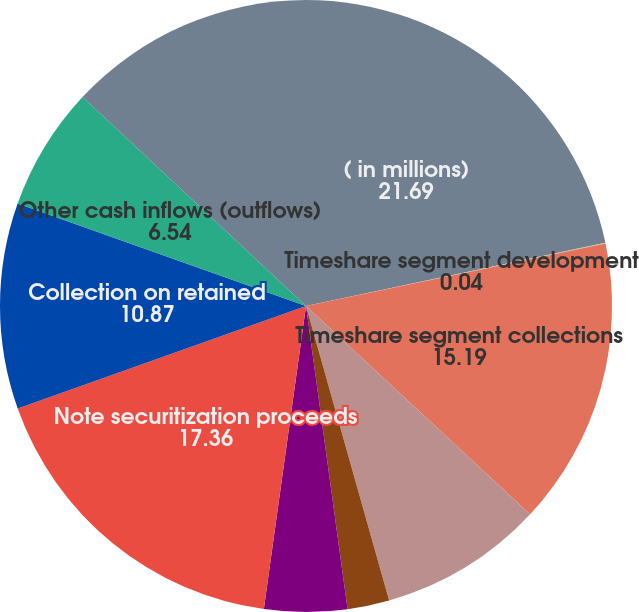Convert chart to OTSL. <chart><loc_0><loc_0><loc_500><loc_500><pie_chart><fcel>( in millions)<fcel>Timeshare segment development<fcel>Timeshare segment collections<fcel>Note repurchases<fcel>Financially reportable sales<fcel>Note securitization gains<fcel>Note securitization proceeds<fcel>Collection on retained<fcel>Other cash inflows (outflows)<fcel>Net cash inflows (outflows)<nl><fcel>21.69%<fcel>0.04%<fcel>15.19%<fcel>8.7%<fcel>2.21%<fcel>4.37%<fcel>17.36%<fcel>10.87%<fcel>6.54%<fcel>13.03%<nl></chart> 